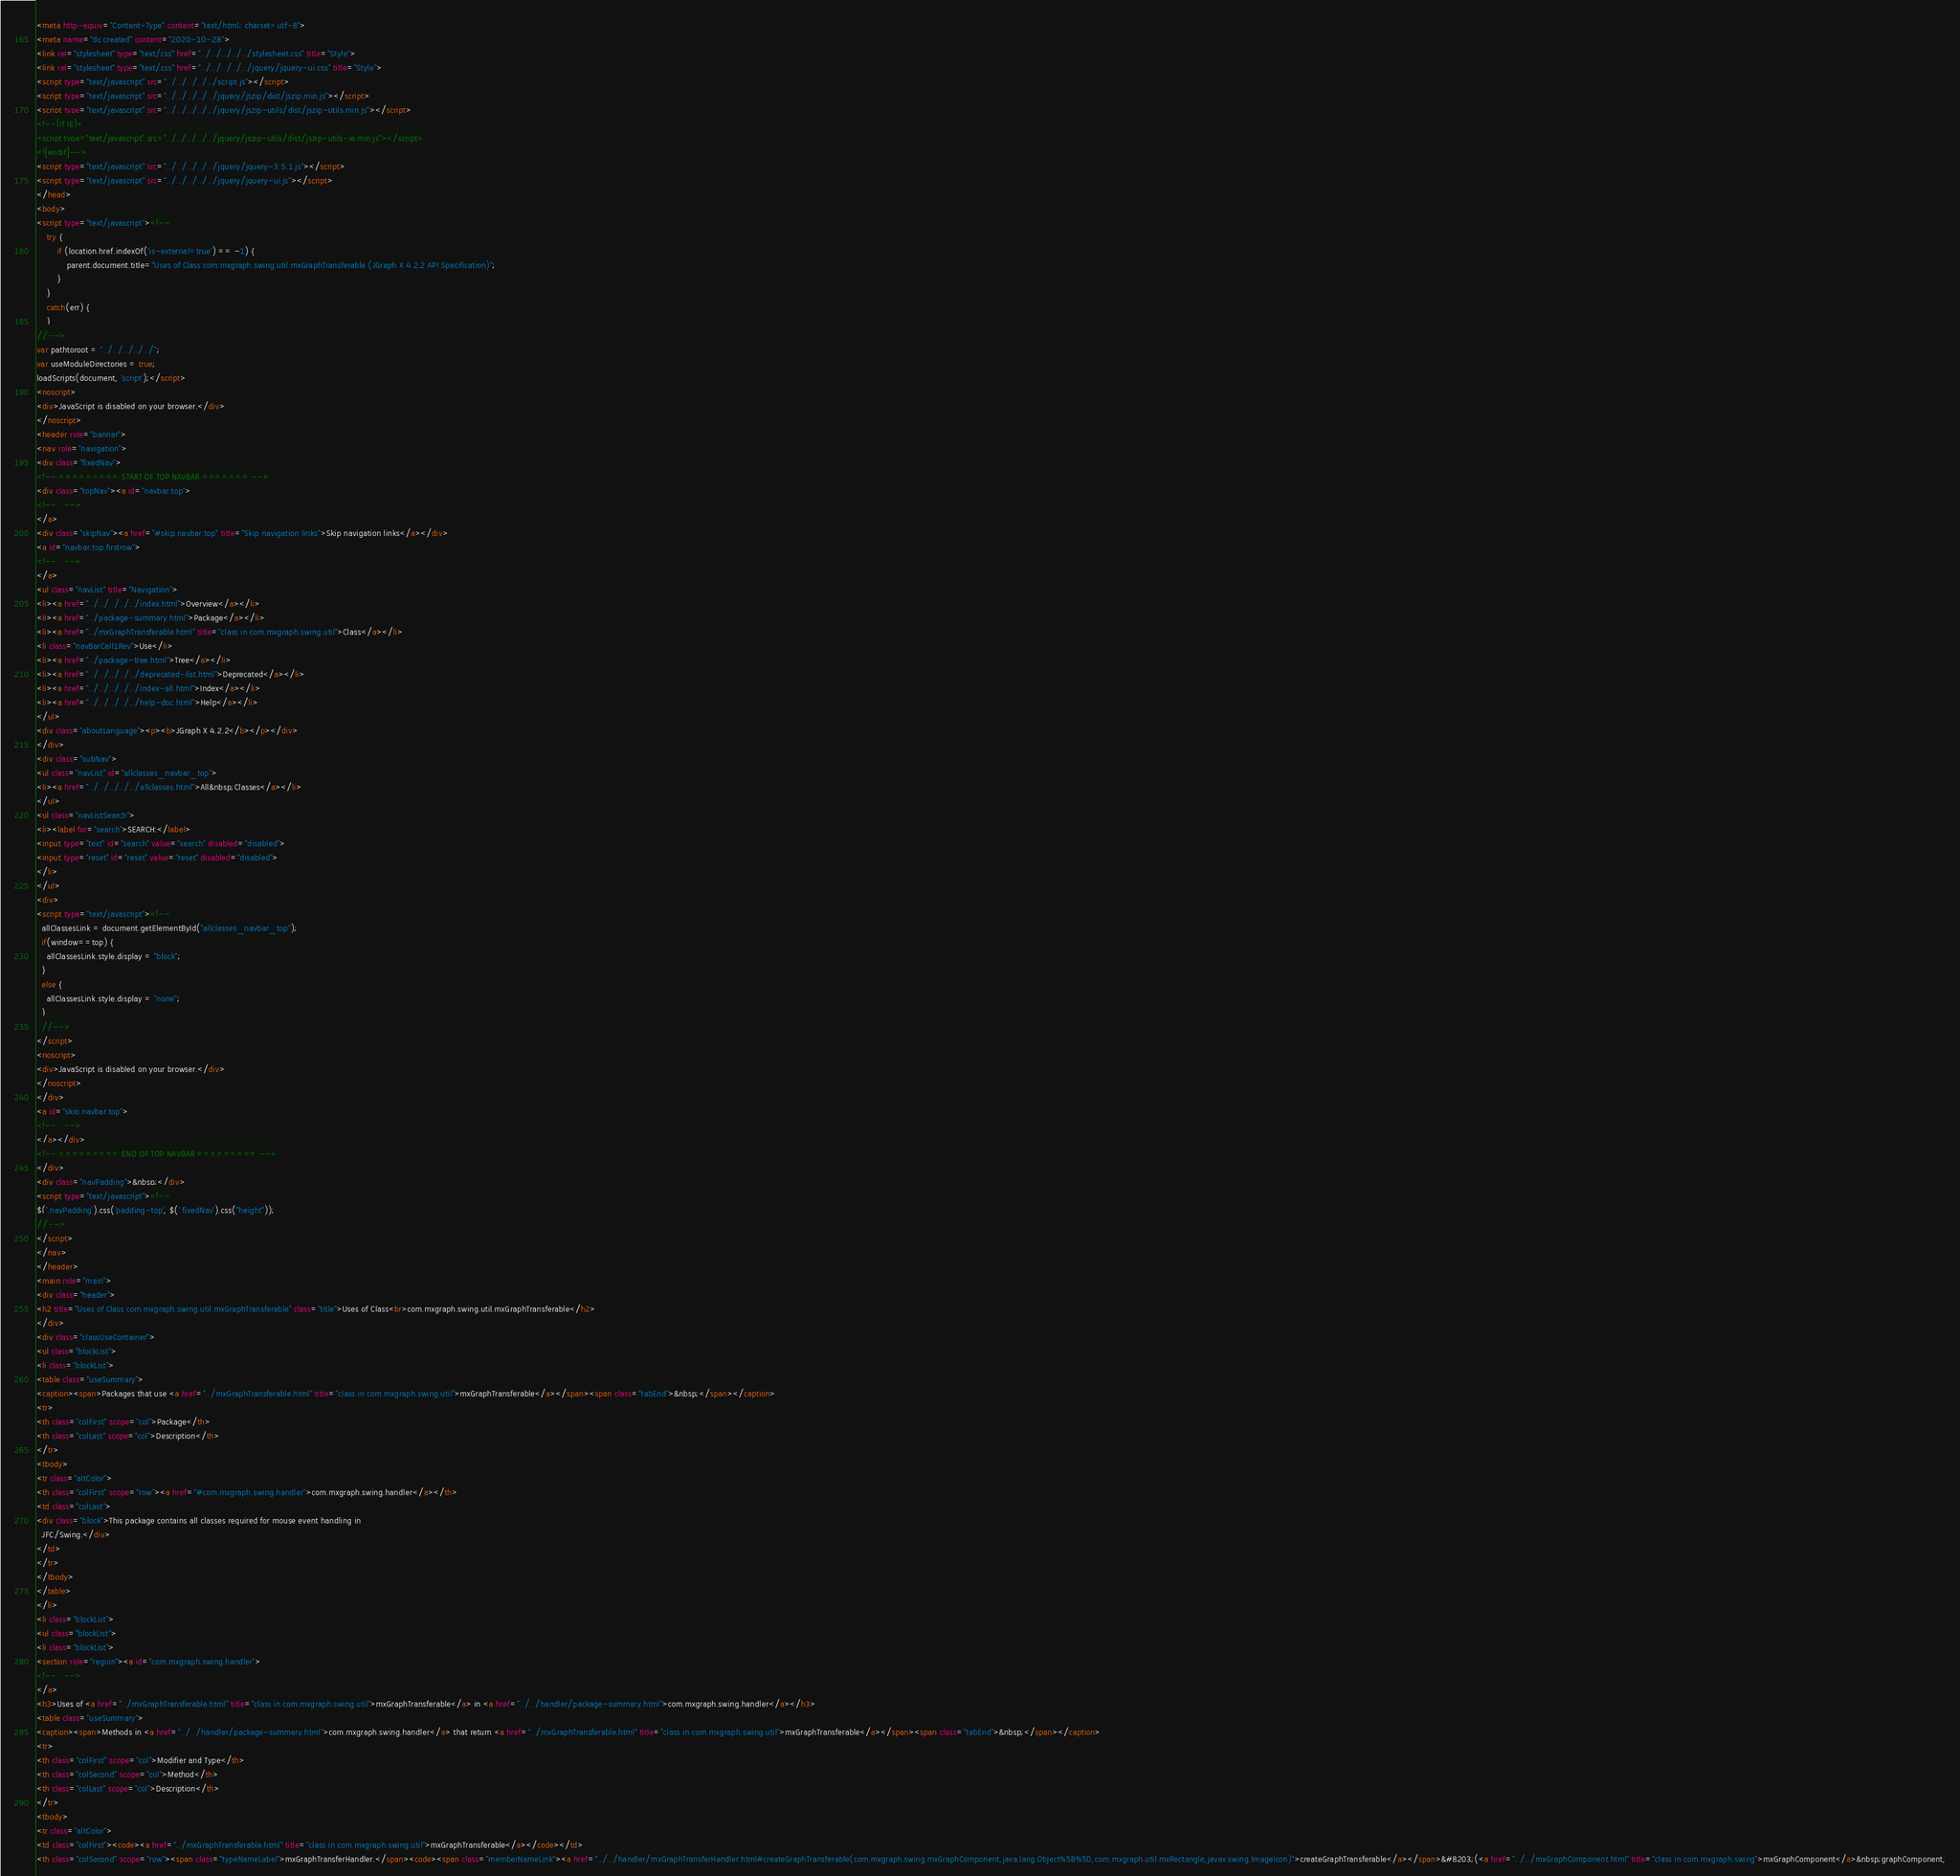<code> <loc_0><loc_0><loc_500><loc_500><_HTML_><meta http-equiv="Content-Type" content="text/html; charset=utf-8">
<meta name="dc.created" content="2020-10-28">
<link rel="stylesheet" type="text/css" href="../../../../../stylesheet.css" title="Style">
<link rel="stylesheet" type="text/css" href="../../../../../jquery/jquery-ui.css" title="Style">
<script type="text/javascript" src="../../../../../script.js"></script>
<script type="text/javascript" src="../../../../../jquery/jszip/dist/jszip.min.js"></script>
<script type="text/javascript" src="../../../../../jquery/jszip-utils/dist/jszip-utils.min.js"></script>
<!--[if IE]>
<script type="text/javascript" src="../../../../../jquery/jszip-utils/dist/jszip-utils-ie.min.js"></script>
<![endif]-->
<script type="text/javascript" src="../../../../../jquery/jquery-3.5.1.js"></script>
<script type="text/javascript" src="../../../../../jquery/jquery-ui.js"></script>
</head>
<body>
<script type="text/javascript"><!--
    try {
        if (location.href.indexOf('is-external=true') == -1) {
            parent.document.title="Uses of Class com.mxgraph.swing.util.mxGraphTransferable (JGraph X 4.2.2 API Specification)";
        }
    }
    catch(err) {
    }
//-->
var pathtoroot = "../../../../../";
var useModuleDirectories = true;
loadScripts(document, 'script');</script>
<noscript>
<div>JavaScript is disabled on your browser.</div>
</noscript>
<header role="banner">
<nav role="navigation">
<div class="fixedNav">
<!-- ========= START OF TOP NAVBAR ======= -->
<div class="topNav"><a id="navbar.top">
<!--   -->
</a>
<div class="skipNav"><a href="#skip.navbar.top" title="Skip navigation links">Skip navigation links</a></div>
<a id="navbar.top.firstrow">
<!--   -->
</a>
<ul class="navList" title="Navigation">
<li><a href="../../../../../index.html">Overview</a></li>
<li><a href="../package-summary.html">Package</a></li>
<li><a href="../mxGraphTransferable.html" title="class in com.mxgraph.swing.util">Class</a></li>
<li class="navBarCell1Rev">Use</li>
<li><a href="../package-tree.html">Tree</a></li>
<li><a href="../../../../../deprecated-list.html">Deprecated</a></li>
<li><a href="../../../../../index-all.html">Index</a></li>
<li><a href="../../../../../help-doc.html">Help</a></li>
</ul>
<div class="aboutLanguage"><p><b>JGraph X 4.2.2</b></p></div>
</div>
<div class="subNav">
<ul class="navList" id="allclasses_navbar_top">
<li><a href="../../../../../allclasses.html">All&nbsp;Classes</a></li>
</ul>
<ul class="navListSearch">
<li><label for="search">SEARCH:</label>
<input type="text" id="search" value="search" disabled="disabled">
<input type="reset" id="reset" value="reset" disabled="disabled">
</li>
</ul>
<div>
<script type="text/javascript"><!--
  allClassesLink = document.getElementById("allclasses_navbar_top");
  if(window==top) {
    allClassesLink.style.display = "block";
  }
  else {
    allClassesLink.style.display = "none";
  }
  //-->
</script>
<noscript>
<div>JavaScript is disabled on your browser.</div>
</noscript>
</div>
<a id="skip.navbar.top">
<!--   -->
</a></div>
<!-- ========= END OF TOP NAVBAR ========= -->
</div>
<div class="navPadding">&nbsp;</div>
<script type="text/javascript"><!--
$('.navPadding').css('padding-top', $('.fixedNav').css("height"));
//-->
</script>
</nav>
</header>
<main role="main">
<div class="header">
<h2 title="Uses of Class com.mxgraph.swing.util.mxGraphTransferable" class="title">Uses of Class<br>com.mxgraph.swing.util.mxGraphTransferable</h2>
</div>
<div class="classUseContainer">
<ul class="blockList">
<li class="blockList">
<table class="useSummary">
<caption><span>Packages that use <a href="../mxGraphTransferable.html" title="class in com.mxgraph.swing.util">mxGraphTransferable</a></span><span class="tabEnd">&nbsp;</span></caption>
<tr>
<th class="colFirst" scope="col">Package</th>
<th class="colLast" scope="col">Description</th>
</tr>
<tbody>
<tr class="altColor">
<th class="colFirst" scope="row"><a href="#com.mxgraph.swing.handler">com.mxgraph.swing.handler</a></th>
<td class="colLast">
<div class="block">This package contains all classes required for mouse event handling in
  JFC/Swing.</div>
</td>
</tr>
</tbody>
</table>
</li>
<li class="blockList">
<ul class="blockList">
<li class="blockList">
<section role="region"><a id="com.mxgraph.swing.handler">
<!--   -->
</a>
<h3>Uses of <a href="../mxGraphTransferable.html" title="class in com.mxgraph.swing.util">mxGraphTransferable</a> in <a href="../../handler/package-summary.html">com.mxgraph.swing.handler</a></h3>
<table class="useSummary">
<caption><span>Methods in <a href="../../handler/package-summary.html">com.mxgraph.swing.handler</a> that return <a href="../mxGraphTransferable.html" title="class in com.mxgraph.swing.util">mxGraphTransferable</a></span><span class="tabEnd">&nbsp;</span></caption>
<tr>
<th class="colFirst" scope="col">Modifier and Type</th>
<th class="colSecond" scope="col">Method</th>
<th class="colLast" scope="col">Description</th>
</tr>
<tbody>
<tr class="altColor">
<td class="colFirst"><code><a href="../mxGraphTransferable.html" title="class in com.mxgraph.swing.util">mxGraphTransferable</a></code></td>
<th class="colSecond" scope="row"><span class="typeNameLabel">mxGraphTransferHandler.</span><code><span class="memberNameLink"><a href="../../handler/mxGraphTransferHandler.html#createGraphTransferable(com.mxgraph.swing.mxGraphComponent,java.lang.Object%5B%5D,com.mxgraph.util.mxRectangle,javax.swing.ImageIcon)">createGraphTransferable</a></span>&#8203;(<a href="../../mxGraphComponent.html" title="class in com.mxgraph.swing">mxGraphComponent</a>&nbsp;graphComponent,</code> 